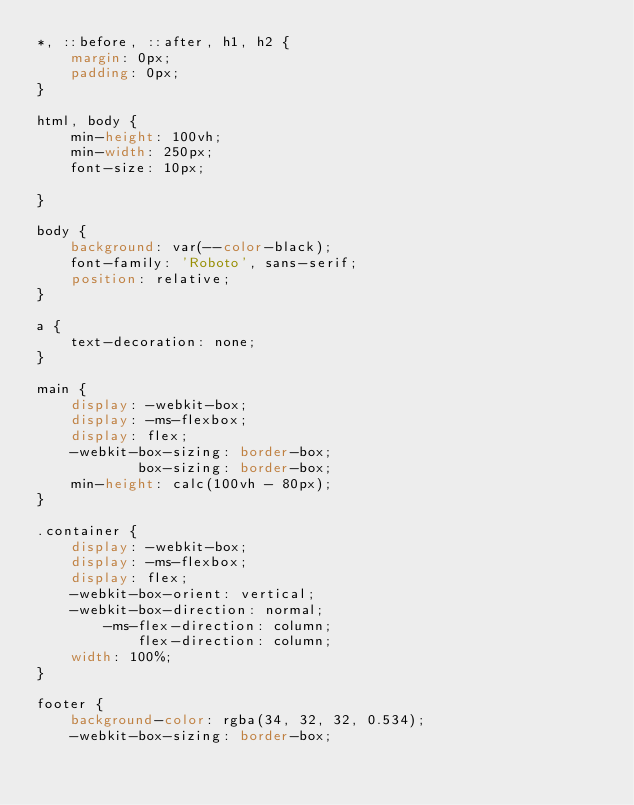<code> <loc_0><loc_0><loc_500><loc_500><_CSS_>*, ::before, ::after, h1, h2 {
    margin: 0px;
    padding: 0px;
}

html, body {
    min-height: 100vh;
    min-width: 250px;
    font-size: 10px;

}

body {
    background: var(--color-black);
    font-family: 'Roboto', sans-serif;
    position: relative;
}

a {
    text-decoration: none;
}

main {
    display: -webkit-box;
    display: -ms-flexbox;
    display: flex;
    -webkit-box-sizing: border-box;
            box-sizing: border-box;
    min-height: calc(100vh - 80px);
}

.container {
    display: -webkit-box;
    display: -ms-flexbox;
    display: flex;
    -webkit-box-orient: vertical;
    -webkit-box-direction: normal;
        -ms-flex-direction: column;
            flex-direction: column;
    width: 100%;
}

footer {
    background-color: rgba(34, 32, 32, 0.534);
    -webkit-box-sizing: border-box;</code> 